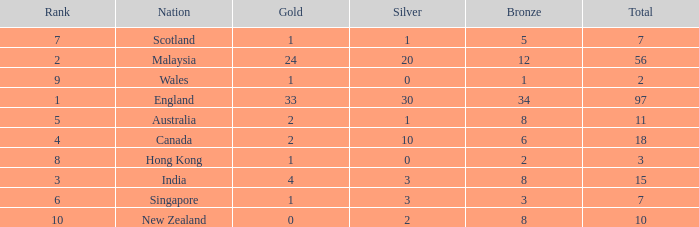What is the number of bronze that Scotland, which has less than 7 total medals, has? None. 